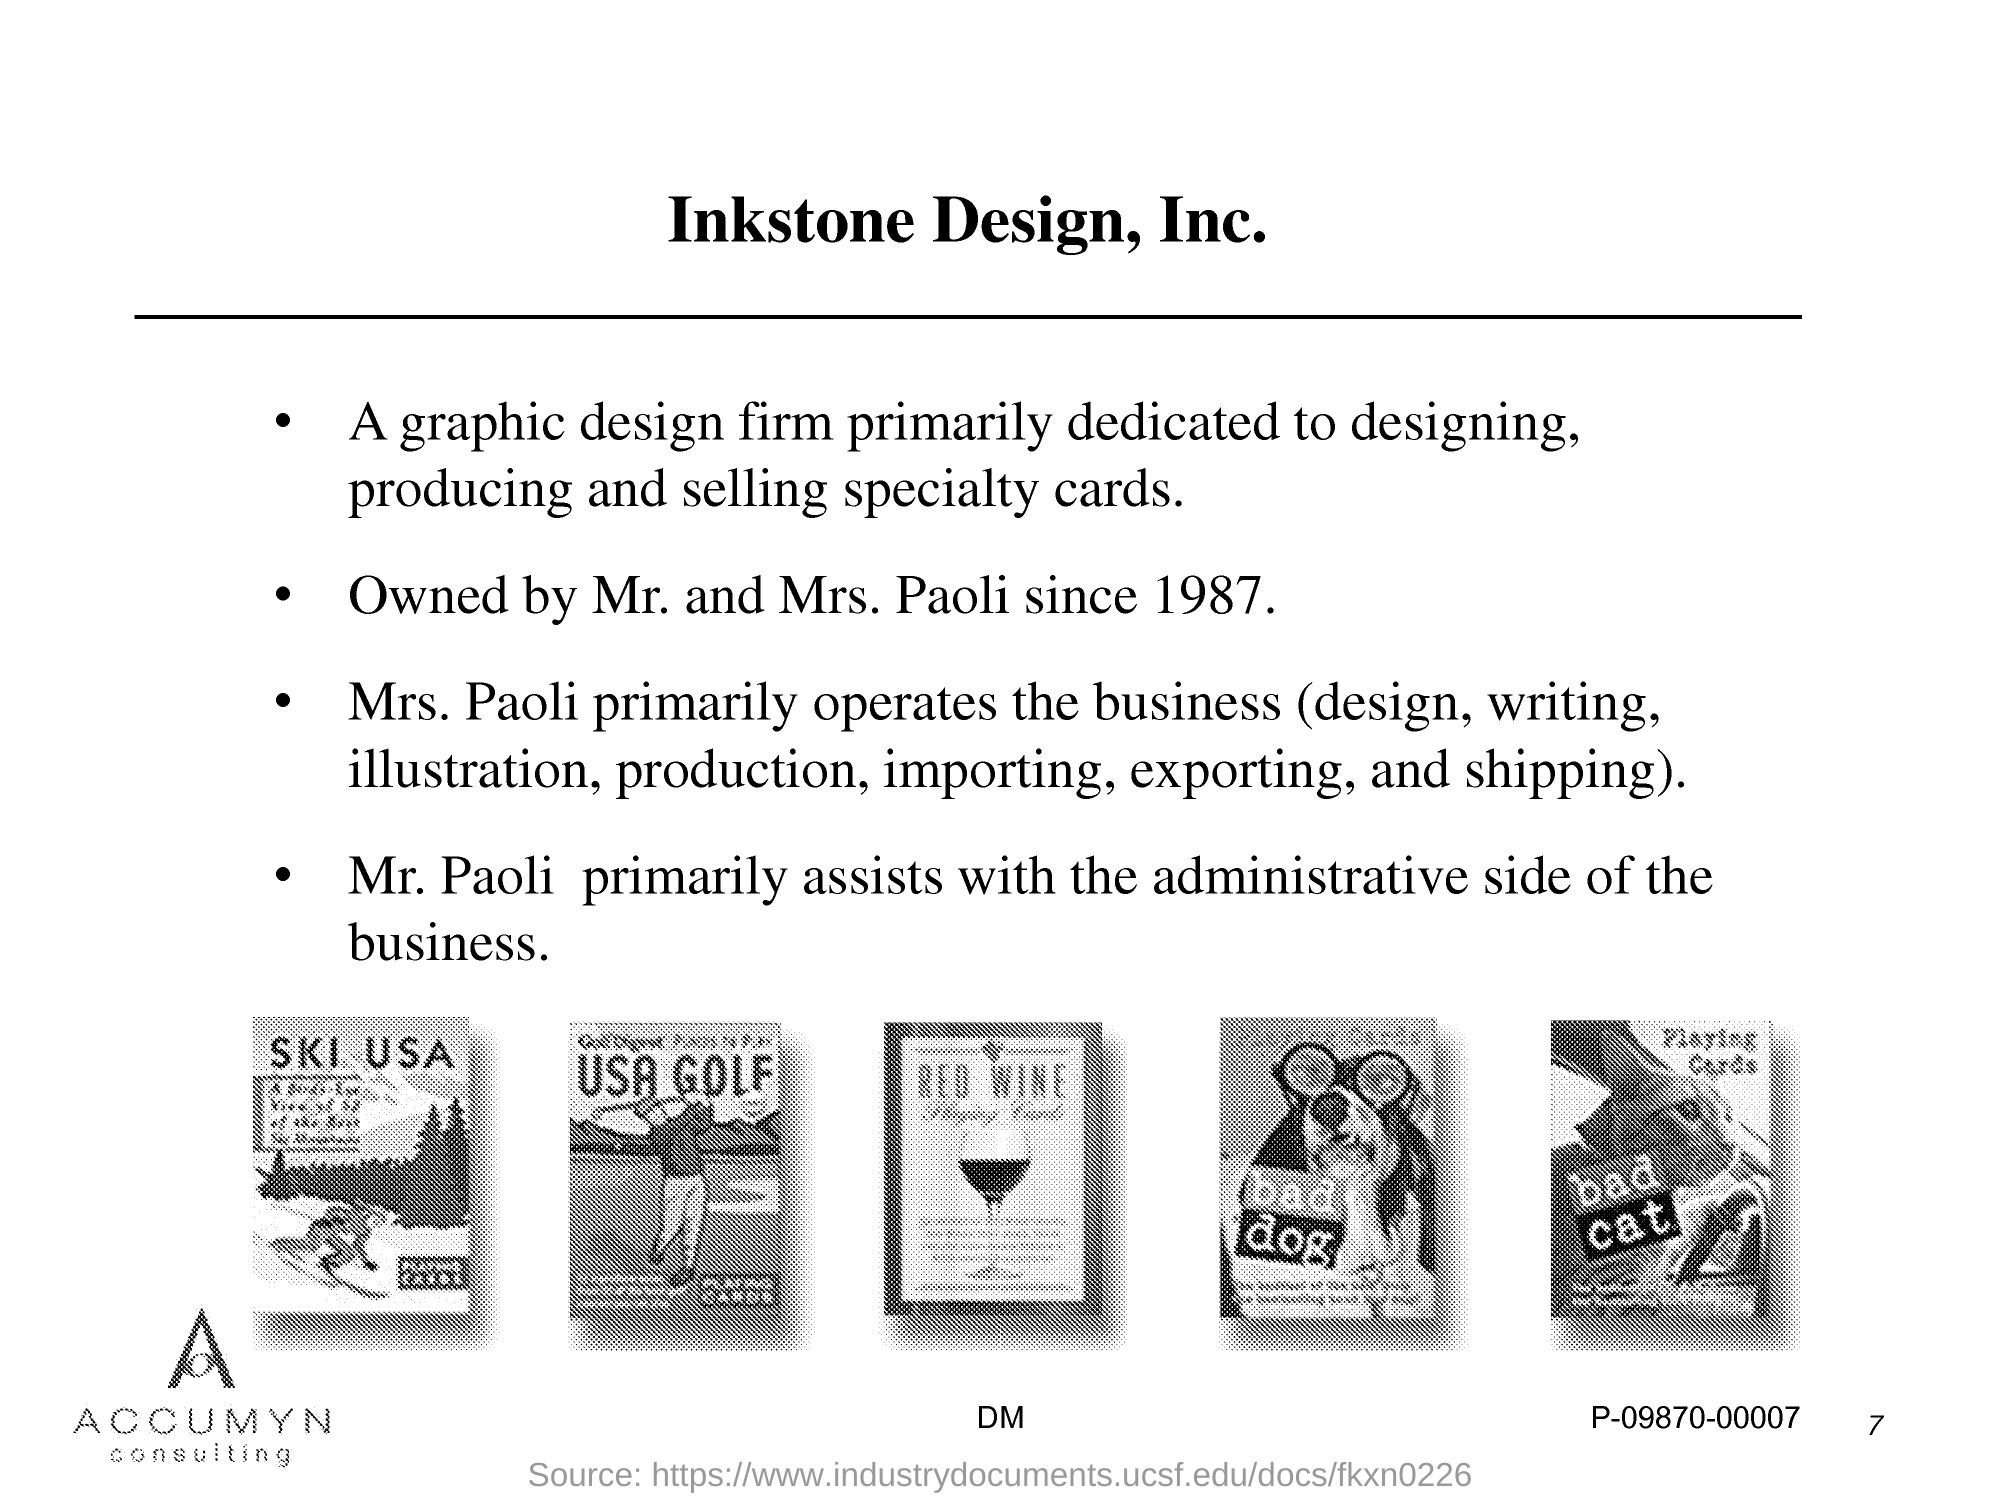What is the Page Number?
Give a very brief answer. 7. 